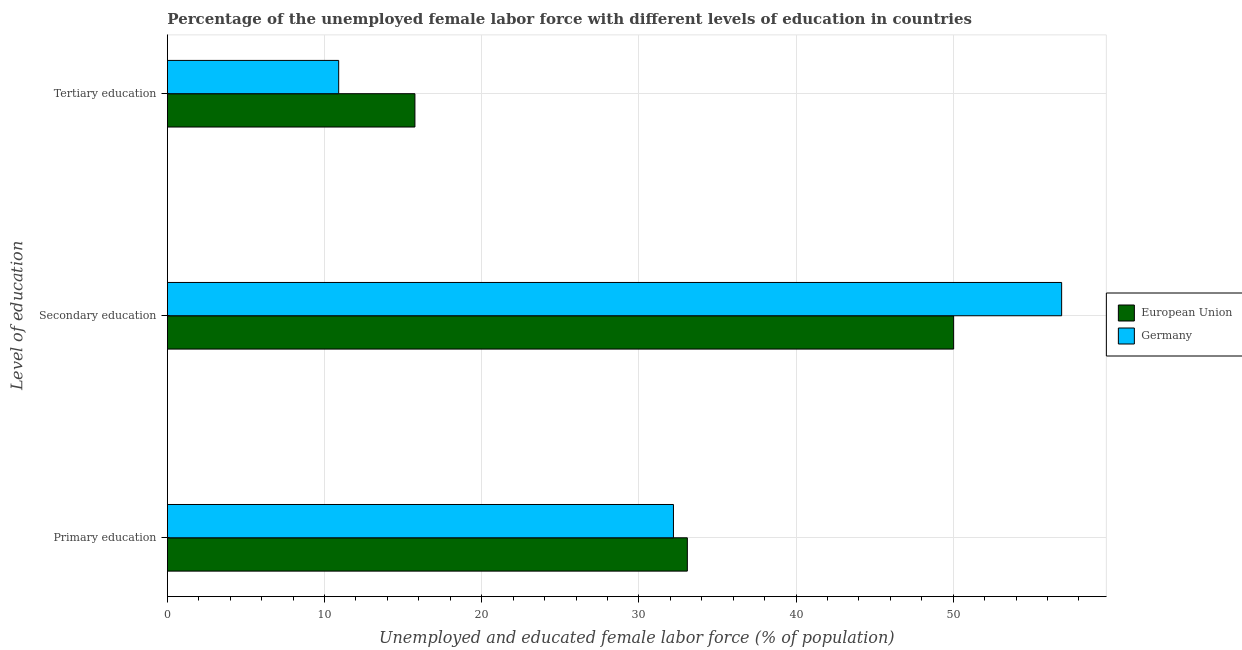How many groups of bars are there?
Provide a succinct answer. 3. Are the number of bars per tick equal to the number of legend labels?
Your response must be concise. Yes. How many bars are there on the 1st tick from the top?
Keep it short and to the point. 2. What is the label of the 2nd group of bars from the top?
Provide a short and direct response. Secondary education. What is the percentage of female labor force who received secondary education in European Union?
Ensure brevity in your answer.  50.03. Across all countries, what is the maximum percentage of female labor force who received secondary education?
Keep it short and to the point. 56.9. Across all countries, what is the minimum percentage of female labor force who received primary education?
Provide a succinct answer. 32.2. In which country was the percentage of female labor force who received primary education minimum?
Keep it short and to the point. Germany. What is the total percentage of female labor force who received tertiary education in the graph?
Ensure brevity in your answer.  26.65. What is the difference between the percentage of female labor force who received primary education in European Union and that in Germany?
Keep it short and to the point. 0.88. What is the difference between the percentage of female labor force who received secondary education in Germany and the percentage of female labor force who received primary education in European Union?
Your answer should be compact. 23.82. What is the average percentage of female labor force who received tertiary education per country?
Your response must be concise. 13.33. What is the difference between the percentage of female labor force who received primary education and percentage of female labor force who received secondary education in Germany?
Offer a terse response. -24.7. What is the ratio of the percentage of female labor force who received tertiary education in Germany to that in European Union?
Make the answer very short. 0.69. What is the difference between the highest and the second highest percentage of female labor force who received primary education?
Offer a very short reply. 0.88. What is the difference between the highest and the lowest percentage of female labor force who received secondary education?
Your answer should be compact. 6.87. In how many countries, is the percentage of female labor force who received primary education greater than the average percentage of female labor force who received primary education taken over all countries?
Keep it short and to the point. 1. Is the sum of the percentage of female labor force who received tertiary education in Germany and European Union greater than the maximum percentage of female labor force who received secondary education across all countries?
Your response must be concise. No. What does the 1st bar from the top in Secondary education represents?
Ensure brevity in your answer.  Germany. What does the 1st bar from the bottom in Tertiary education represents?
Make the answer very short. European Union. Is it the case that in every country, the sum of the percentage of female labor force who received primary education and percentage of female labor force who received secondary education is greater than the percentage of female labor force who received tertiary education?
Provide a succinct answer. Yes. How many countries are there in the graph?
Make the answer very short. 2. Are the values on the major ticks of X-axis written in scientific E-notation?
Ensure brevity in your answer.  No. Does the graph contain any zero values?
Give a very brief answer. No. Does the graph contain grids?
Offer a very short reply. Yes. How are the legend labels stacked?
Offer a very short reply. Vertical. What is the title of the graph?
Give a very brief answer. Percentage of the unemployed female labor force with different levels of education in countries. Does "Bermuda" appear as one of the legend labels in the graph?
Your answer should be very brief. No. What is the label or title of the X-axis?
Offer a terse response. Unemployed and educated female labor force (% of population). What is the label or title of the Y-axis?
Ensure brevity in your answer.  Level of education. What is the Unemployed and educated female labor force (% of population) in European Union in Primary education?
Your answer should be compact. 33.08. What is the Unemployed and educated female labor force (% of population) of Germany in Primary education?
Ensure brevity in your answer.  32.2. What is the Unemployed and educated female labor force (% of population) in European Union in Secondary education?
Keep it short and to the point. 50.03. What is the Unemployed and educated female labor force (% of population) of Germany in Secondary education?
Offer a terse response. 56.9. What is the Unemployed and educated female labor force (% of population) in European Union in Tertiary education?
Give a very brief answer. 15.75. What is the Unemployed and educated female labor force (% of population) in Germany in Tertiary education?
Your answer should be compact. 10.9. Across all Level of education, what is the maximum Unemployed and educated female labor force (% of population) in European Union?
Your answer should be very brief. 50.03. Across all Level of education, what is the maximum Unemployed and educated female labor force (% of population) in Germany?
Provide a short and direct response. 56.9. Across all Level of education, what is the minimum Unemployed and educated female labor force (% of population) of European Union?
Offer a terse response. 15.75. Across all Level of education, what is the minimum Unemployed and educated female labor force (% of population) of Germany?
Your response must be concise. 10.9. What is the total Unemployed and educated female labor force (% of population) of European Union in the graph?
Offer a very short reply. 98.86. What is the difference between the Unemployed and educated female labor force (% of population) of European Union in Primary education and that in Secondary education?
Provide a succinct answer. -16.94. What is the difference between the Unemployed and educated female labor force (% of population) in Germany in Primary education and that in Secondary education?
Give a very brief answer. -24.7. What is the difference between the Unemployed and educated female labor force (% of population) of European Union in Primary education and that in Tertiary education?
Make the answer very short. 17.33. What is the difference between the Unemployed and educated female labor force (% of population) in Germany in Primary education and that in Tertiary education?
Your answer should be compact. 21.3. What is the difference between the Unemployed and educated female labor force (% of population) in European Union in Secondary education and that in Tertiary education?
Your response must be concise. 34.28. What is the difference between the Unemployed and educated female labor force (% of population) in European Union in Primary education and the Unemployed and educated female labor force (% of population) in Germany in Secondary education?
Offer a very short reply. -23.82. What is the difference between the Unemployed and educated female labor force (% of population) in European Union in Primary education and the Unemployed and educated female labor force (% of population) in Germany in Tertiary education?
Give a very brief answer. 22.18. What is the difference between the Unemployed and educated female labor force (% of population) in European Union in Secondary education and the Unemployed and educated female labor force (% of population) in Germany in Tertiary education?
Give a very brief answer. 39.13. What is the average Unemployed and educated female labor force (% of population) of European Union per Level of education?
Give a very brief answer. 32.95. What is the average Unemployed and educated female labor force (% of population) of Germany per Level of education?
Make the answer very short. 33.33. What is the difference between the Unemployed and educated female labor force (% of population) in European Union and Unemployed and educated female labor force (% of population) in Germany in Primary education?
Give a very brief answer. 0.88. What is the difference between the Unemployed and educated female labor force (% of population) of European Union and Unemployed and educated female labor force (% of population) of Germany in Secondary education?
Offer a very short reply. -6.87. What is the difference between the Unemployed and educated female labor force (% of population) of European Union and Unemployed and educated female labor force (% of population) of Germany in Tertiary education?
Offer a terse response. 4.85. What is the ratio of the Unemployed and educated female labor force (% of population) of European Union in Primary education to that in Secondary education?
Your response must be concise. 0.66. What is the ratio of the Unemployed and educated female labor force (% of population) of Germany in Primary education to that in Secondary education?
Your answer should be compact. 0.57. What is the ratio of the Unemployed and educated female labor force (% of population) of European Union in Primary education to that in Tertiary education?
Keep it short and to the point. 2.1. What is the ratio of the Unemployed and educated female labor force (% of population) of Germany in Primary education to that in Tertiary education?
Your response must be concise. 2.95. What is the ratio of the Unemployed and educated female labor force (% of population) of European Union in Secondary education to that in Tertiary education?
Provide a short and direct response. 3.18. What is the ratio of the Unemployed and educated female labor force (% of population) in Germany in Secondary education to that in Tertiary education?
Your answer should be very brief. 5.22. What is the difference between the highest and the second highest Unemployed and educated female labor force (% of population) of European Union?
Provide a short and direct response. 16.94. What is the difference between the highest and the second highest Unemployed and educated female labor force (% of population) in Germany?
Provide a short and direct response. 24.7. What is the difference between the highest and the lowest Unemployed and educated female labor force (% of population) in European Union?
Your answer should be very brief. 34.28. What is the difference between the highest and the lowest Unemployed and educated female labor force (% of population) in Germany?
Give a very brief answer. 46. 